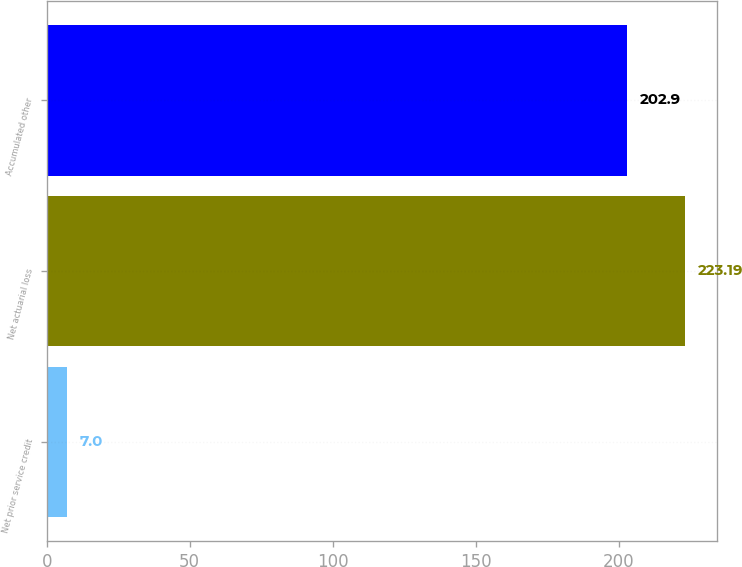Convert chart. <chart><loc_0><loc_0><loc_500><loc_500><bar_chart><fcel>Net prior service credit<fcel>Net actuarial loss<fcel>Accumulated other<nl><fcel>7<fcel>223.19<fcel>202.9<nl></chart> 